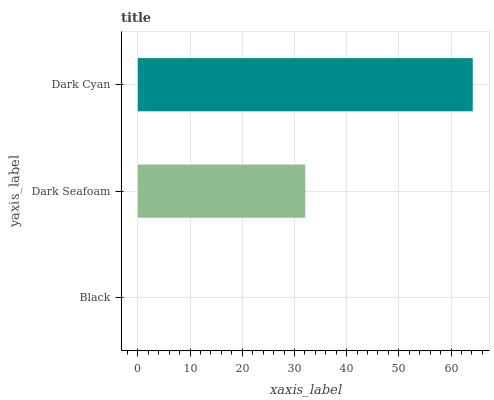Is Black the minimum?
Answer yes or no. Yes. Is Dark Cyan the maximum?
Answer yes or no. Yes. Is Dark Seafoam the minimum?
Answer yes or no. No. Is Dark Seafoam the maximum?
Answer yes or no. No. Is Dark Seafoam greater than Black?
Answer yes or no. Yes. Is Black less than Dark Seafoam?
Answer yes or no. Yes. Is Black greater than Dark Seafoam?
Answer yes or no. No. Is Dark Seafoam less than Black?
Answer yes or no. No. Is Dark Seafoam the high median?
Answer yes or no. Yes. Is Dark Seafoam the low median?
Answer yes or no. Yes. Is Black the high median?
Answer yes or no. No. Is Dark Cyan the low median?
Answer yes or no. No. 